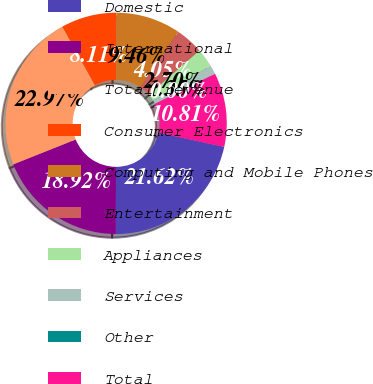<chart> <loc_0><loc_0><loc_500><loc_500><pie_chart><fcel>Domestic<fcel>International<fcel>Total revenue<fcel>Consumer Electronics<fcel>Computing and Mobile Phones<fcel>Entertainment<fcel>Appliances<fcel>Services<fcel>Other<fcel>Total<nl><fcel>21.62%<fcel>18.92%<fcel>22.97%<fcel>8.11%<fcel>9.46%<fcel>4.05%<fcel>2.7%<fcel>1.35%<fcel>0.0%<fcel>10.81%<nl></chart> 